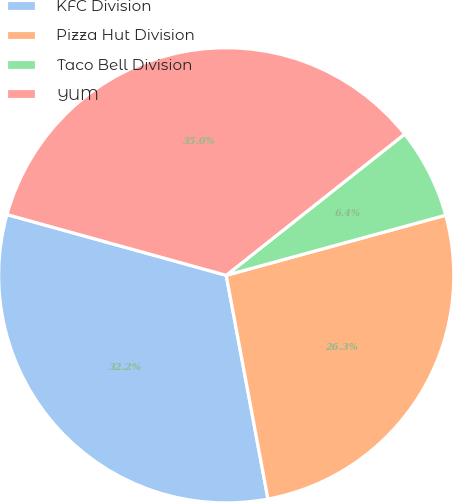Convert chart. <chart><loc_0><loc_0><loc_500><loc_500><pie_chart><fcel>KFC Division<fcel>Pizza Hut Division<fcel>Taco Bell Division<fcel>YUM<nl><fcel>32.24%<fcel>26.32%<fcel>6.4%<fcel>35.04%<nl></chart> 